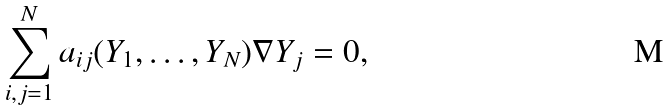<formula> <loc_0><loc_0><loc_500><loc_500>\sum ^ { N } _ { i , j = 1 } a _ { i j } ( Y _ { 1 } , \dots , Y _ { N } ) \nabla Y _ { j } = 0 ,</formula> 